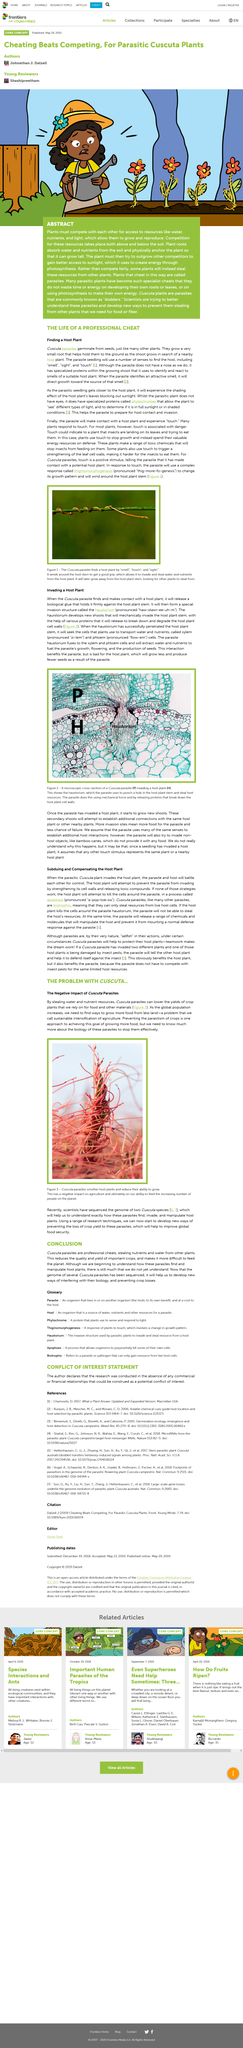List a handful of essential elements in this visual. Yes, Cuscata is a parasite. To improve global food security, it is essential to develop innovative methods for preventing the loss of crop yield due to parasites. It is known that some parasites are able to locate their hosts through sensory cues such as "smell," "touch," and "sight. The parasite haustorium fuses with xylem and phloem cells in the host plant. The haustorium is a specialized invasion structure that enables parasitic plants to infiltrate their host plant and extract nutrients for their own growth and development. 